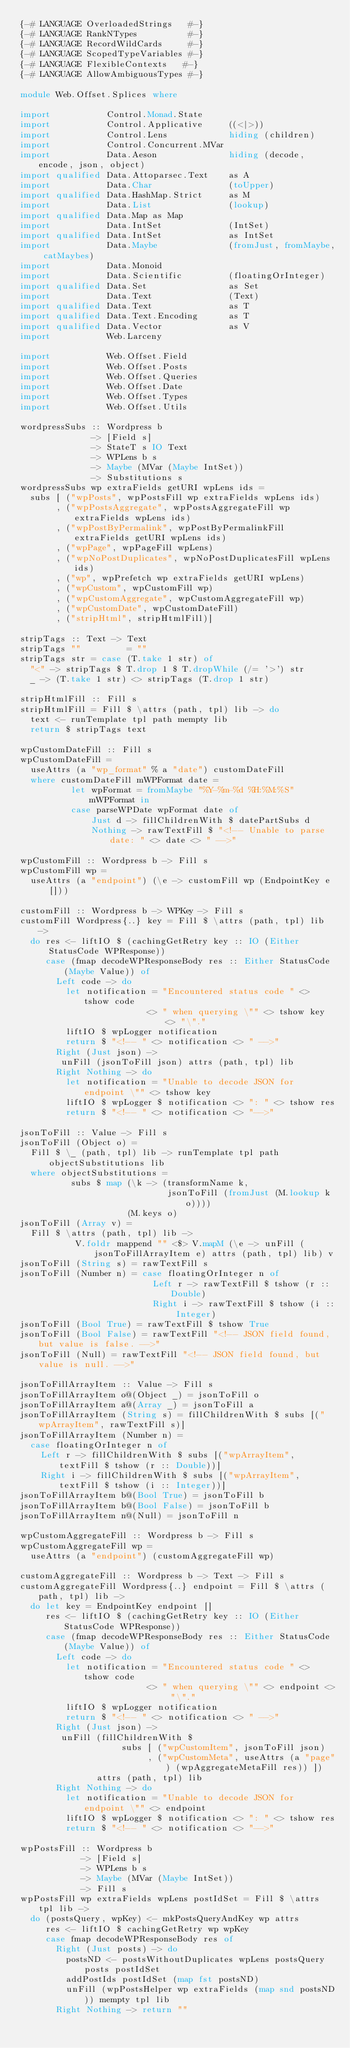<code> <loc_0><loc_0><loc_500><loc_500><_Haskell_>{-# LANGUAGE OverloadedStrings   #-}
{-# LANGUAGE RankNTypes          #-}
{-# LANGUAGE RecordWildCards     #-}
{-# LANGUAGE ScopedTypeVariables #-}
{-# LANGUAGE FlexibleContexts   #-}
{-# LANGUAGE AllowAmbiguousTypes #-}

module Web.Offset.Splices where

import           Control.Monad.State
import           Control.Applicative     ((<|>))
import           Control.Lens            hiding (children)
import           Control.Concurrent.MVar
import           Data.Aeson              hiding (decode, encode, json, object)
import qualified Data.Attoparsec.Text    as A
import           Data.Char               (toUpper)
import qualified Data.HashMap.Strict     as M
import           Data.List               (lookup)
import qualified Data.Map as Map
import           Data.IntSet             (IntSet)
import qualified Data.IntSet             as IntSet
import           Data.Maybe              (fromJust, fromMaybe, catMaybes)
import           Data.Monoid
import           Data.Scientific         (floatingOrInteger)
import qualified Data.Set                as Set
import           Data.Text               (Text)
import qualified Data.Text               as T
import qualified Data.Text.Encoding      as T
import qualified Data.Vector             as V
import           Web.Larceny

import           Web.Offset.Field
import           Web.Offset.Posts
import           Web.Offset.Queries
import           Web.Offset.Date
import           Web.Offset.Types
import           Web.Offset.Utils

wordpressSubs :: Wordpress b
              -> [Field s]
              -> StateT s IO Text
              -> WPLens b s
              -> Maybe (MVar (Maybe IntSet))
              -> Substitutions s
wordpressSubs wp extraFields getURI wpLens ids =
  subs [ ("wpPosts", wpPostsFill wp extraFields wpLens ids)
       , ("wpPostsAggregate", wpPostsAggregateFill wp extraFields wpLens ids)
       , ("wpPostByPermalink", wpPostByPermalinkFill extraFields getURI wpLens ids)
       , ("wpPage", wpPageFill wpLens)
       , ("wpNoPostDuplicates", wpNoPostDuplicatesFill wpLens ids)
       , ("wp", wpPrefetch wp extraFields getURI wpLens)
       , ("wpCustom", wpCustomFill wp)
       , ("wpCustomAggregate", wpCustomAggregateFill wp)
       , ("wpCustomDate", wpCustomDateFill)
       , ("stripHtml", stripHtmlFill)]

stripTags :: Text -> Text
stripTags ""         = ""
stripTags str = case (T.take 1 str) of
  "<" -> stripTags $ T.drop 1 $ T.dropWhile (/= '>') str
  _ -> (T.take 1 str) <> stripTags (T.drop 1 str)

stripHtmlFill :: Fill s
stripHtmlFill = Fill $ \attrs (path, tpl) lib -> do
  text <- runTemplate tpl path mempty lib
  return $ stripTags text

wpCustomDateFill :: Fill s
wpCustomDateFill =
  useAttrs (a "wp_format" % a "date") customDateFill
  where customDateFill mWPFormat date =
          let wpFormat = fromMaybe "%Y-%m-%d %H:%M:%S" mWPFormat in
          case parseWPDate wpFormat date of
              Just d -> fillChildrenWith $ datePartSubs d
              Nothing -> rawTextFill $ "<!-- Unable to parse date: " <> date <> " -->"

wpCustomFill :: Wordpress b -> Fill s
wpCustomFill wp =
  useAttrs (a "endpoint") (\e -> customFill wp (EndpointKey e []))

customFill :: Wordpress b -> WPKey -> Fill s
customFill Wordpress{..} key = Fill $ \attrs (path, tpl) lib ->
  do res <- liftIO $ (cachingGetRetry key :: IO (Either StatusCode WPResponse))
     case (fmap decodeWPResponseBody res :: Either StatusCode (Maybe Value)) of
       Left code -> do
         let notification = "Encountered status code " <> tshow code
                         <> " when querying \"" <> tshow key <> "\"."
         liftIO $ wpLogger notification
         return $ "<!-- " <> notification <> " -->"
       Right (Just json) ->
        unFill (jsonToFill json) attrs (path, tpl) lib
       Right Nothing -> do
         let notification = "Unable to decode JSON for endpoint \"" <> tshow key
         liftIO $ wpLogger $ notification <> ": " <> tshow res
         return $ "<!-- " <> notification <> "-->"

jsonToFill :: Value -> Fill s
jsonToFill (Object o) =
  Fill $ \_ (path, tpl) lib -> runTemplate tpl path objectSubstitutions lib
  where objectSubstitutions =
          subs $ map (\k -> (transformName k,
                             jsonToFill (fromJust (M.lookup k o))))
                     (M.keys o)
jsonToFill (Array v) =
  Fill $ \attrs (path, tpl) lib ->
           V.foldr mappend "" <$> V.mapM (\e -> unFill (jsonToFillArrayItem e) attrs (path, tpl) lib) v
jsonToFill (String s) = rawTextFill s
jsonToFill (Number n) = case floatingOrInteger n of
                          Left r -> rawTextFill $ tshow (r :: Double)
                          Right i -> rawTextFill $ tshow (i :: Integer)
jsonToFill (Bool True) = rawTextFill $ tshow True
jsonToFill (Bool False) = rawTextFill "<!-- JSON field found, but value is false. -->"
jsonToFill (Null) = rawTextFill "<!-- JSON field found, but value is null. -->"

jsonToFillArrayItem :: Value -> Fill s
jsonToFillArrayItem o@(Object _) = jsonToFill o
jsonToFillArrayItem a@(Array _) = jsonToFill a
jsonToFillArrayItem (String s) = fillChildrenWith $ subs [("wpArrayItem", rawTextFill s)]
jsonToFillArrayItem (Number n) =
  case floatingOrInteger n of
    Left r -> fillChildrenWith $ subs [("wpArrayItem", textFill $ tshow (r :: Double))]
    Right i -> fillChildrenWith $ subs [("wpArrayItem", textFill $ tshow (i :: Integer))]
jsonToFillArrayItem b@(Bool True) = jsonToFill b
jsonToFillArrayItem b@(Bool False) = jsonToFill b
jsonToFillArrayItem n@(Null) = jsonToFill n

wpCustomAggregateFill :: Wordpress b -> Fill s
wpCustomAggregateFill wp =
  useAttrs (a "endpoint") (customAggregateFill wp)

customAggregateFill :: Wordpress b -> Text -> Fill s
customAggregateFill Wordpress{..} endpoint = Fill $ \attrs (path, tpl) lib ->
  do let key = EndpointKey endpoint []
     res <- liftIO $ (cachingGetRetry key :: IO (Either StatusCode WPResponse))
     case (fmap decodeWPResponseBody res :: Either StatusCode (Maybe Value)) of
       Left code -> do
         let notification = "Encountered status code " <> tshow code
                         <> " when querying \"" <> endpoint <> "\"."
         liftIO $ wpLogger notification
         return $ "<!-- " <> notification <> " -->"
       Right (Just json) ->
        unFill (fillChildrenWith $
                    subs [ ("wpCustomItem", jsonToFill json)
                         , ("wpCustomMeta", useAttrs (a "page") (wpAggregateMetaFill res)) ])
               attrs (path, tpl) lib
       Right Nothing -> do
         let notification = "Unable to decode JSON for endpoint \"" <> endpoint
         liftIO $ wpLogger $ notification <> ": " <> tshow res
         return $ "<!-- " <> notification <> "-->"

wpPostsFill :: Wordpress b
            -> [Field s]
            -> WPLens b s
            -> Maybe (MVar (Maybe IntSet))
            -> Fill s
wpPostsFill wp extraFields wpLens postIdSet = Fill $ \attrs tpl lib ->
  do (postsQuery, wpKey) <- mkPostsQueryAndKey wp attrs
     res <- liftIO $ cachingGetRetry wp wpKey
     case fmap decodeWPResponseBody res of
       Right (Just posts) -> do
         postsND <- postsWithoutDuplicates wpLens postsQuery posts postIdSet
         addPostIds postIdSet (map fst postsND)
         unFill (wpPostsHelper wp extraFields (map snd postsND)) mempty tpl lib
       Right Nothing -> return ""</code> 